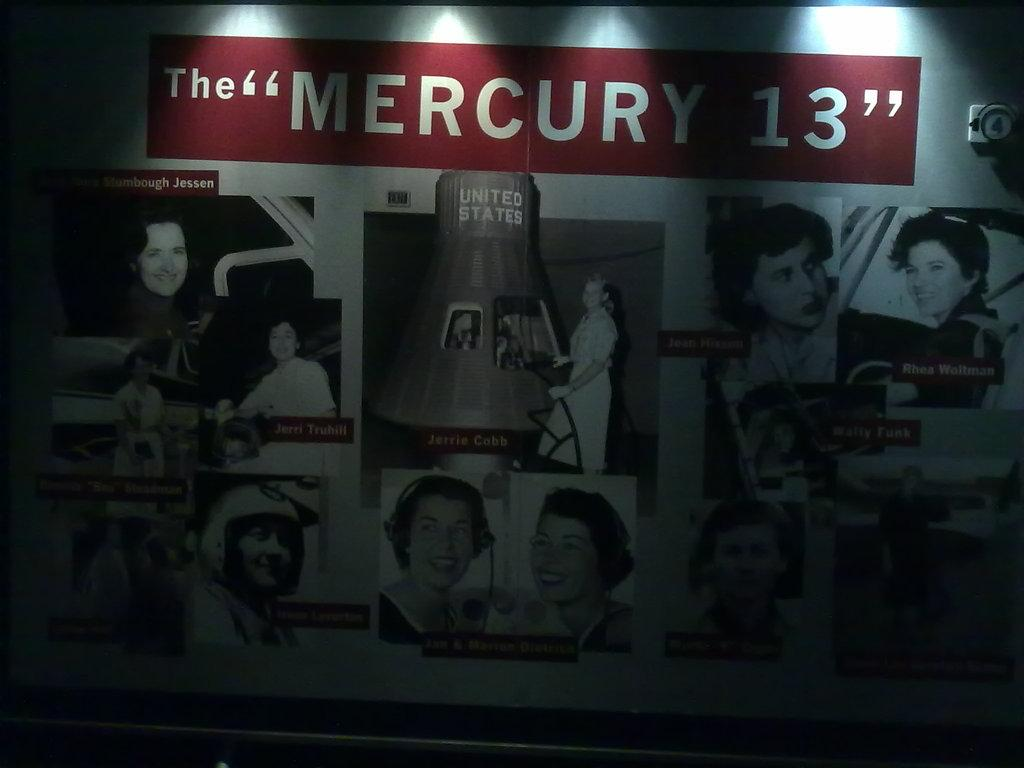What is the main object in the image? There is a board in the image. What can be seen on the board? The board contains images of persons. What color scheme is used for the images on the board? The images are in black and white colors. Is there any text on the board? Yes, there is text on the top of the board. How many lizards are crawling on the board in the image? There are no lizards present on the board in the image. What type of advertisement is displayed on the board? The image does not show any advertisement; it only contains images of persons and text. 